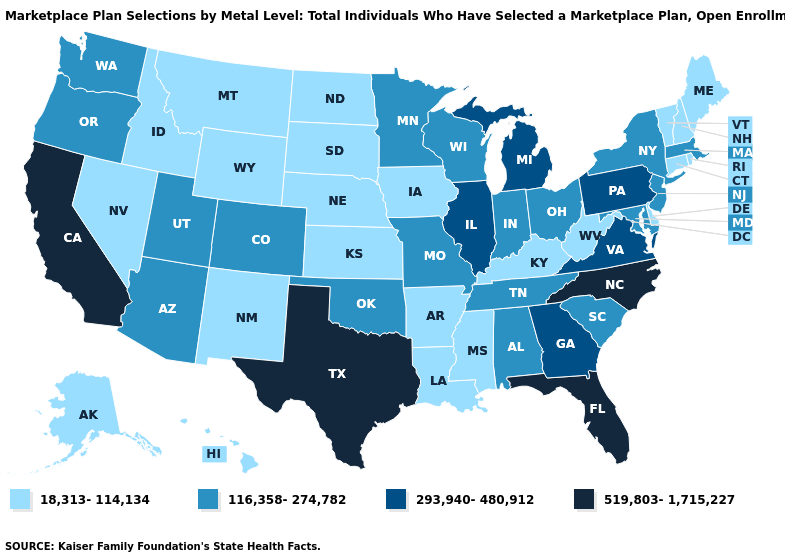Does Louisiana have a lower value than New Hampshire?
Short answer required. No. Name the states that have a value in the range 519,803-1,715,227?
Be succinct. California, Florida, North Carolina, Texas. Does the first symbol in the legend represent the smallest category?
Be succinct. Yes. Does Idaho have the same value as Tennessee?
Be succinct. No. What is the value of Arkansas?
Keep it brief. 18,313-114,134. Does Oklahoma have the lowest value in the USA?
Concise answer only. No. Does Vermont have the highest value in the Northeast?
Write a very short answer. No. What is the highest value in states that border Missouri?
Short answer required. 293,940-480,912. What is the highest value in the West ?
Quick response, please. 519,803-1,715,227. What is the value of Kentucky?
Short answer required. 18,313-114,134. Name the states that have a value in the range 293,940-480,912?
Write a very short answer. Georgia, Illinois, Michigan, Pennsylvania, Virginia. Which states have the lowest value in the USA?
Short answer required. Alaska, Arkansas, Connecticut, Delaware, Hawaii, Idaho, Iowa, Kansas, Kentucky, Louisiana, Maine, Mississippi, Montana, Nebraska, Nevada, New Hampshire, New Mexico, North Dakota, Rhode Island, South Dakota, Vermont, West Virginia, Wyoming. Name the states that have a value in the range 18,313-114,134?
Write a very short answer. Alaska, Arkansas, Connecticut, Delaware, Hawaii, Idaho, Iowa, Kansas, Kentucky, Louisiana, Maine, Mississippi, Montana, Nebraska, Nevada, New Hampshire, New Mexico, North Dakota, Rhode Island, South Dakota, Vermont, West Virginia, Wyoming. Does Kentucky have the highest value in the South?
Keep it brief. No. Among the states that border Ohio , which have the highest value?
Concise answer only. Michigan, Pennsylvania. 